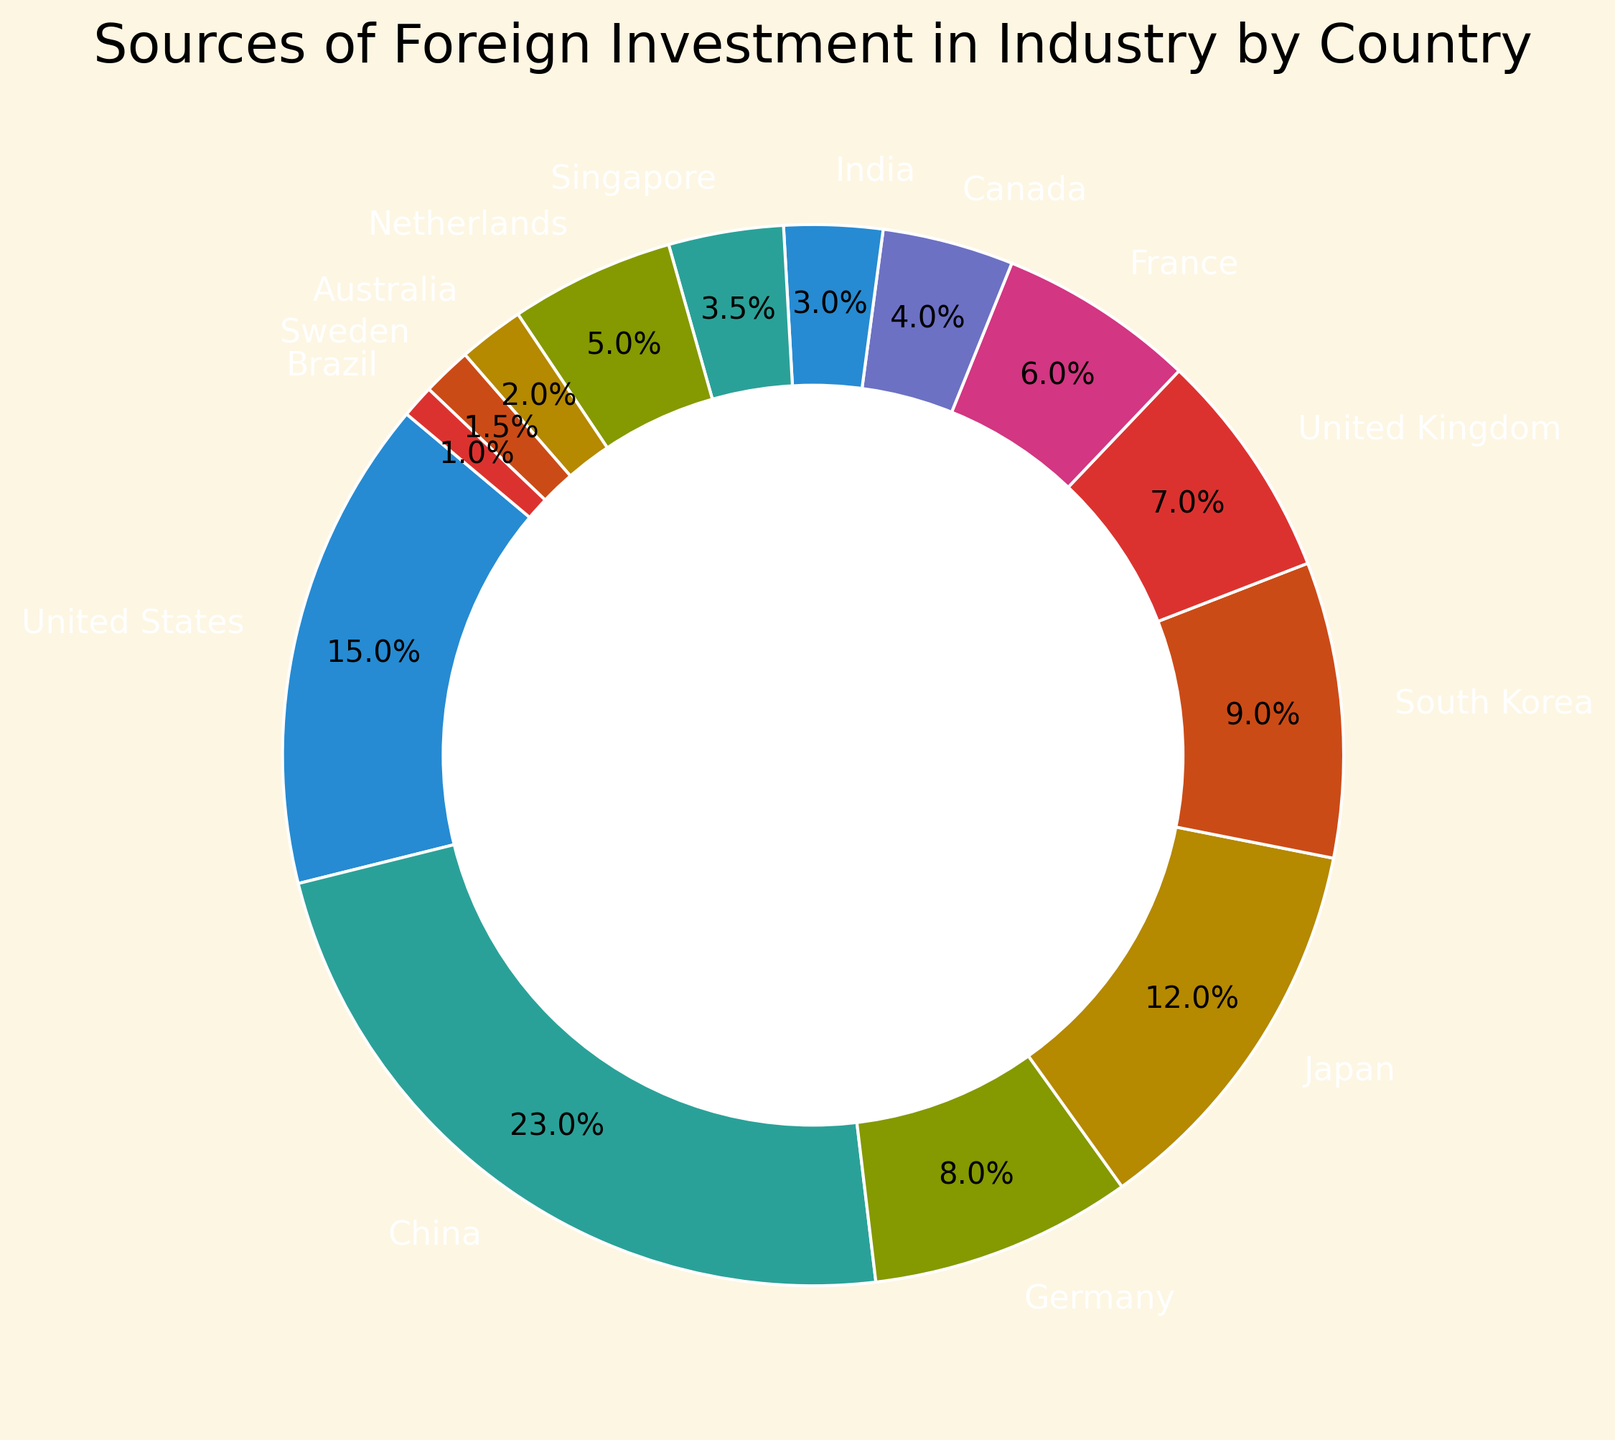Which country has the highest source of foreign investment in industry? By looking at the chart, identify the country with the largest segment. This segment represents the highest investment.
Answer: China What percentage of the total foreign investment in the industry does Japan make up? Check the label for Japan on the chart, which should indicate the percentage of the total investment originating from Japan.
Answer: 12% How does the investment from the United Kingdom compare with that from Germany? Locate the segments representing the United Kingdom and Germany. Compare their sizes and respective percentages.
Answer: The United Kingdom invests less than Germany Which three countries combined contribute the smallest percentage of foreign investment in the industry? Identify the three smallest segments on the ring chart by looking at their respective sizes and percentages.
Answer: Brazil, Sweden, Australia What is the combined investment from South Korea and Singapore? Identify the segments for South Korea and Singapore, sum their values, i.e., 900 + 350 million USD.
Answer: 1,250 million USD Is the investment from the United States greater than the combined investment from France and Canada? Compare the segment for the United States with the sum of the segments for France and Canada.
Answer: Yes Assuming only China and the United States invested, what fraction of the total investment would be from China? Combine the investments from China and the United States, then divide China's investment by this total.
Answer: 2300 / (2300 + 1500) = 2300 / 3800 ≈ 61% Among the investments from Singapore and India, which country contributes more, and by what margin? Compare the segments for Singapore and India, then find the difference in their investments, i.e., 350 - 300 million USD.
Answer: Singapore by 50 million USD What is the total foreign investment in the industry from countries outside the top four contributors? Exclude the top four largest segments (China, United States, Japan, Germany), then sum the values of the remaining segments.
Answer: 3900 million USD Which country out of Japan and South Korea has a higher percentage investment in the industry, and by how much? Compare the percentages for Japan and South Korea by checking their labels, then find the difference, i.e., 12% - 9%.
Answer: Japan by 3% 